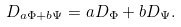Convert formula to latex. <formula><loc_0><loc_0><loc_500><loc_500>D _ { a \Phi + b \Psi } = a D _ { \Phi } + b D _ { \Psi } .</formula> 